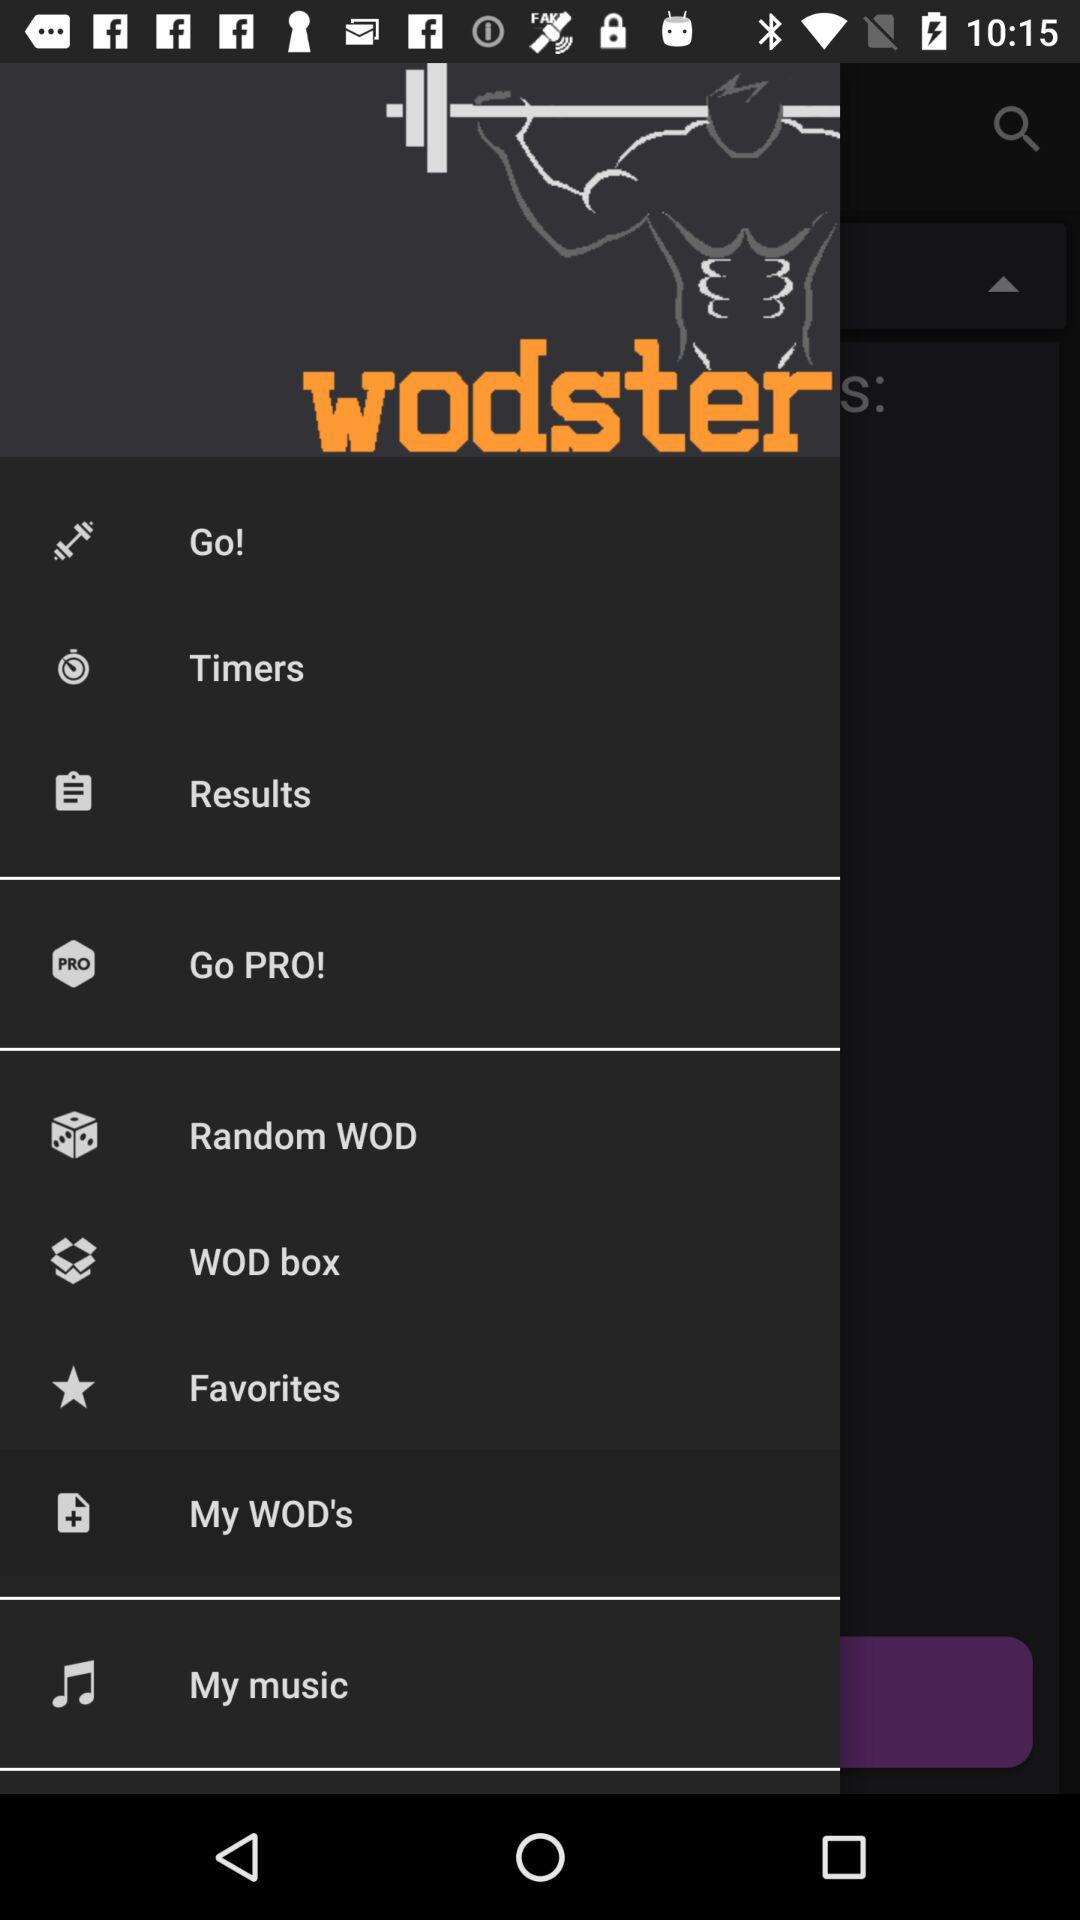What's the selected menu option? The selected menu option is My WOD's. 